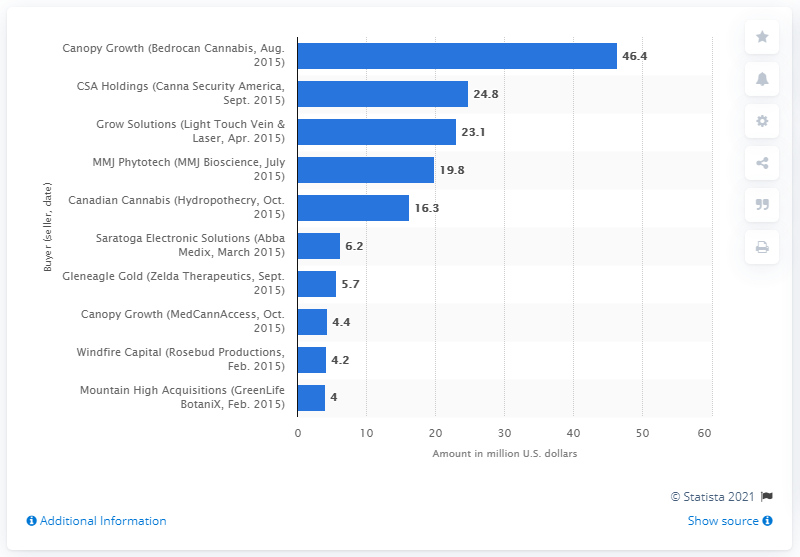List a handful of essential elements in this visual. Canopy Growth paid 46.4 million dollars for Bedrocan Cannabis. 